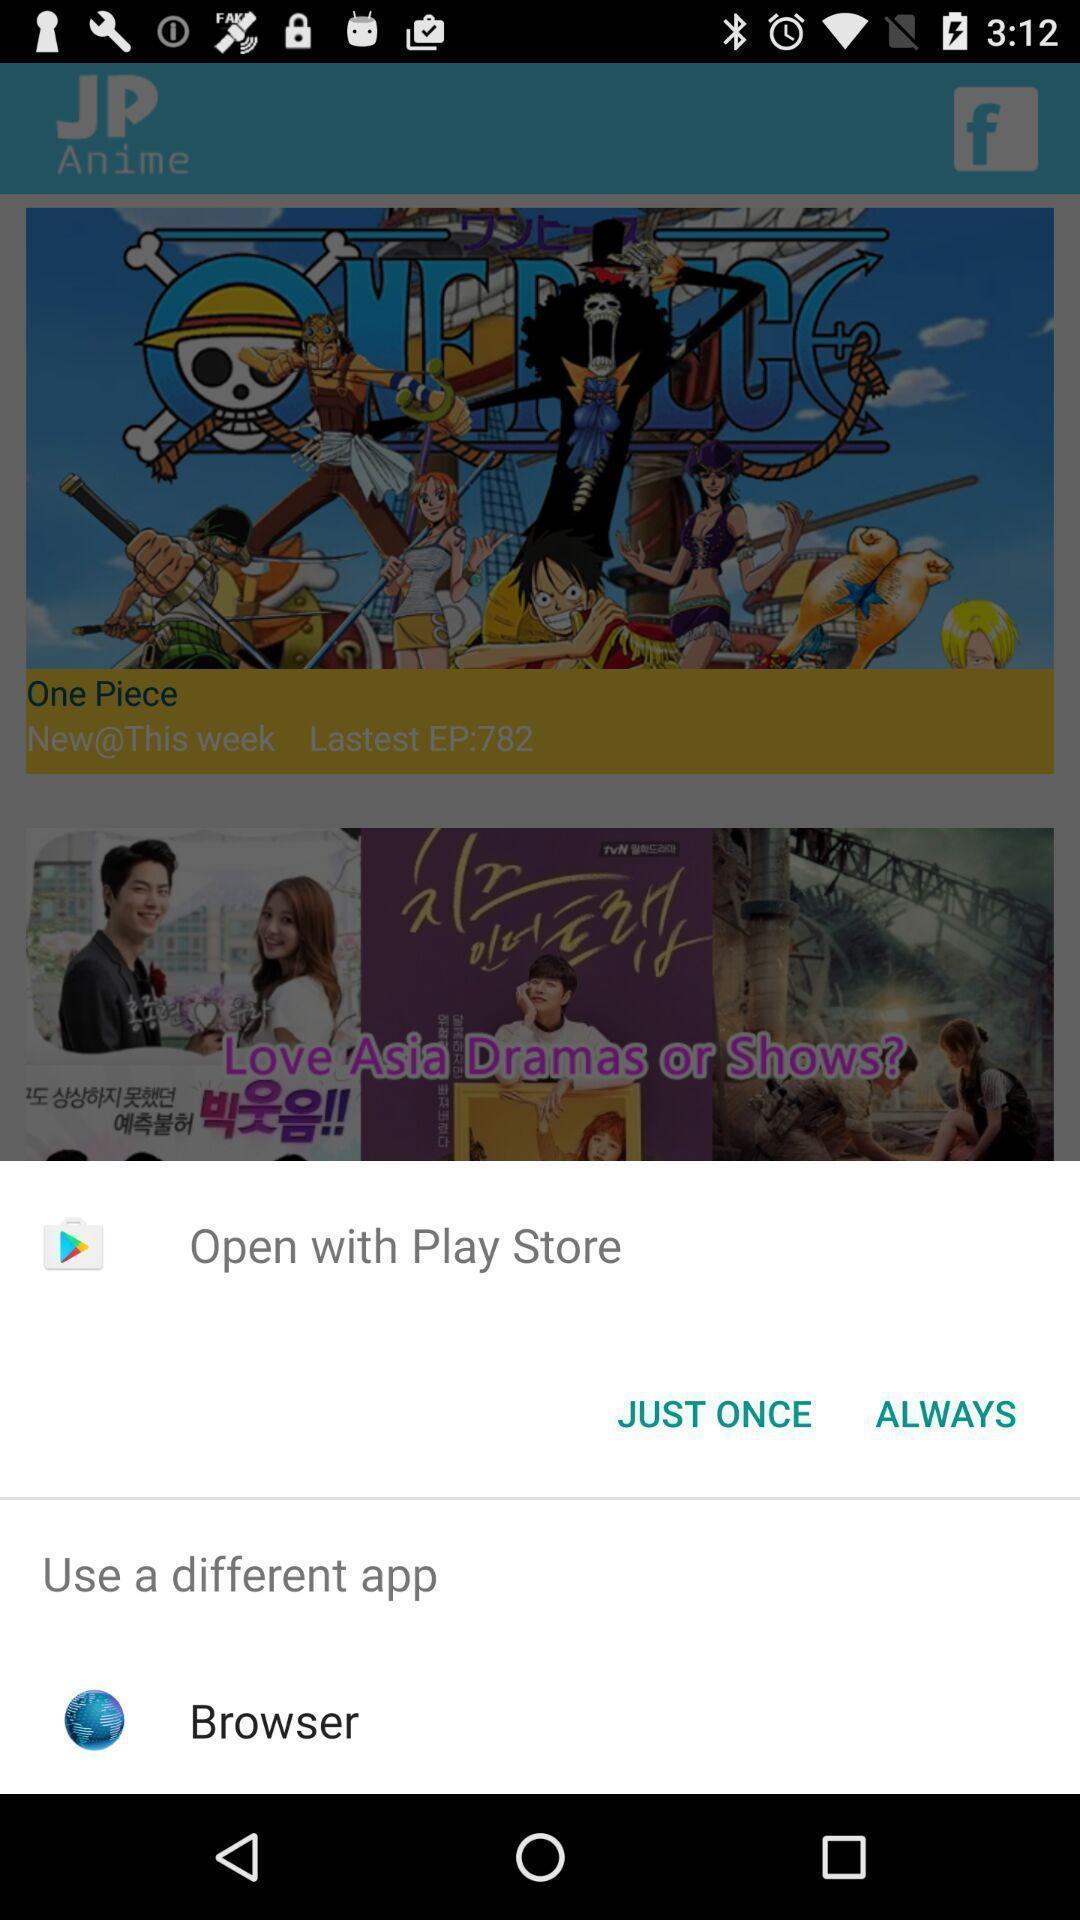Describe the key features of this screenshot. Pop-up widget is displaying browsing options. 